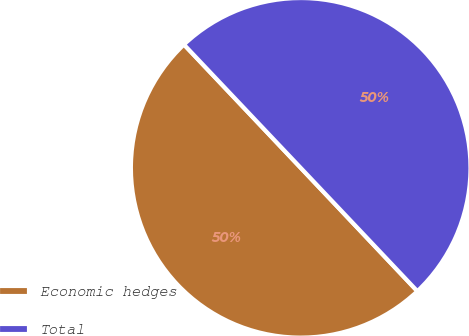<chart> <loc_0><loc_0><loc_500><loc_500><pie_chart><fcel>Economic hedges<fcel>Total<nl><fcel>49.99%<fcel>50.01%<nl></chart> 